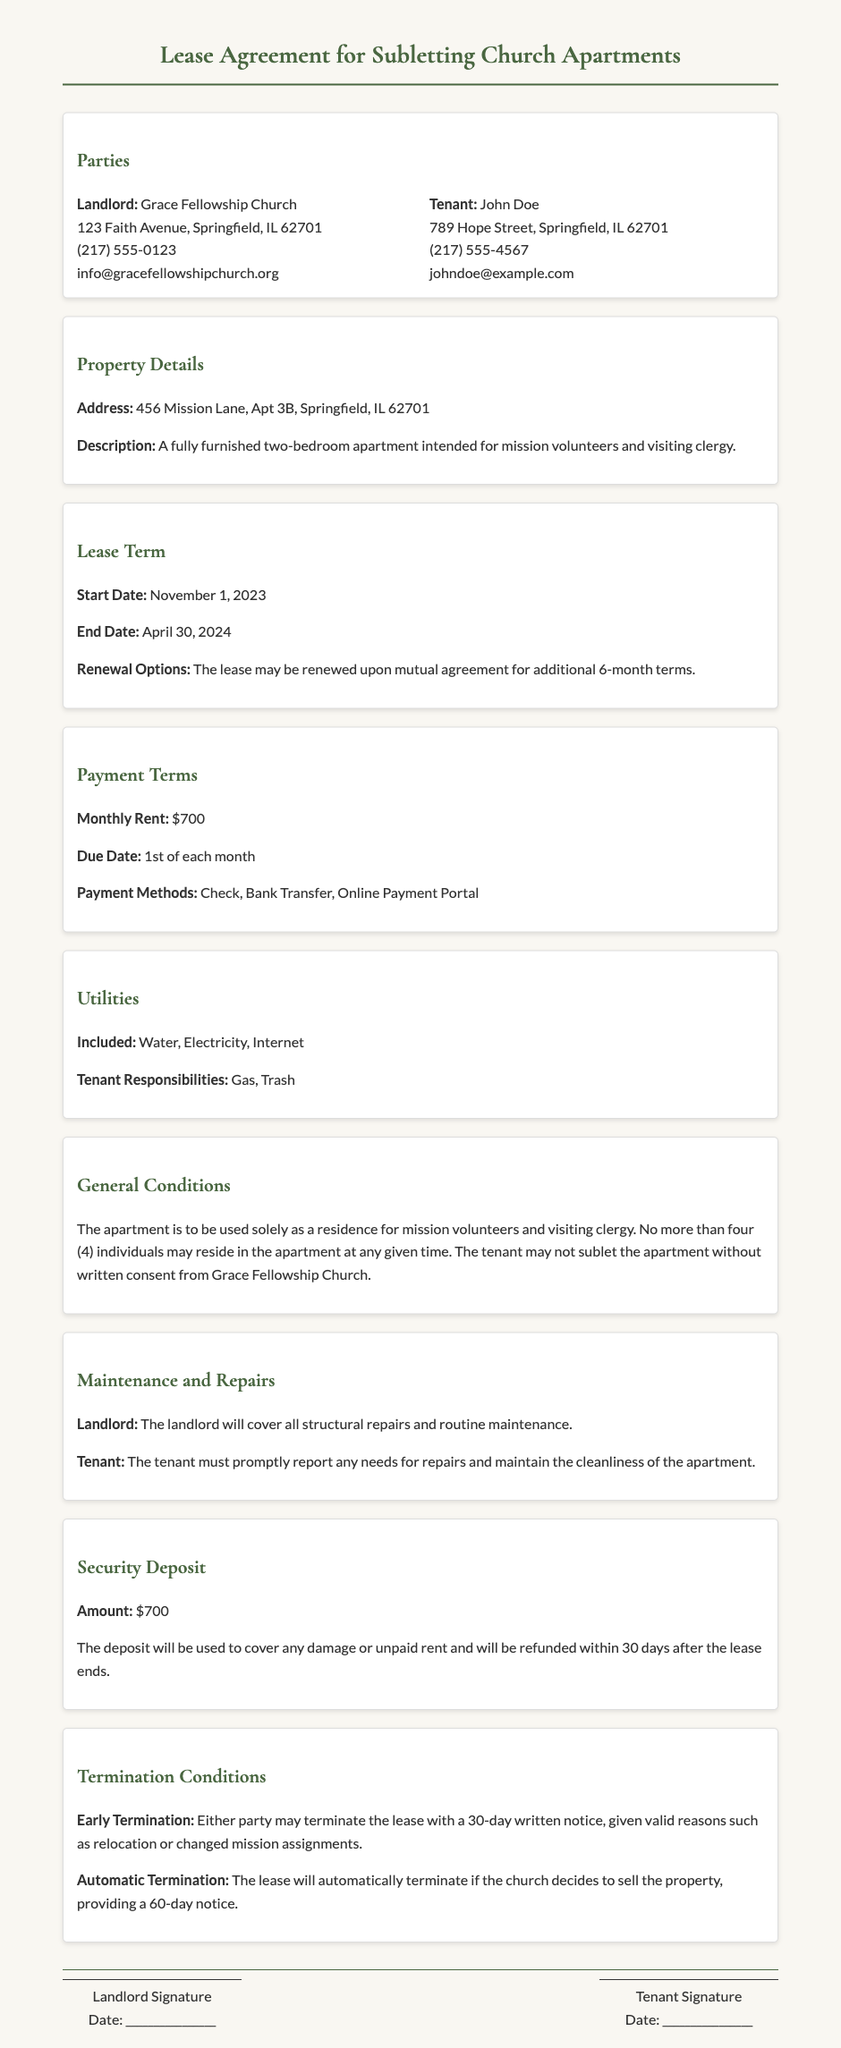What is the address of the property? The address of the property is specified in the document under Property Details.
Answer: 456 Mission Lane, Apt 3B, Springfield, IL 62701 What is the monthly rent? The monthly rent amount is stated in the Payment Terms section of the document.
Answer: $700 When does the lease start? The start date of the lease is mentioned in the Lease Term section.
Answer: November 1, 2023 Who is the landlord? The landlord's name is listed in the Parties section of the document.
Answer: Grace Fellowship Church What are the tenant's responsibilities regarding utilities? The document specifies the utilities that the tenant is responsible for in the Utilities section.
Answer: Gas, Trash How long is the lease term? The lease term duration is indicated by the start and end dates provided in the document.
Answer: 6 months What is required for early termination of the lease? The conditions for early termination are outlined in the Termination Conditions section of the document.
Answer: 30-day written notice Is subletting allowed without consent? The document addresses subletting restrictions in the General Conditions section.
Answer: No What is the security deposit amount? The amount of the security deposit is specified in the Security Deposit section of the document.
Answer: $700 